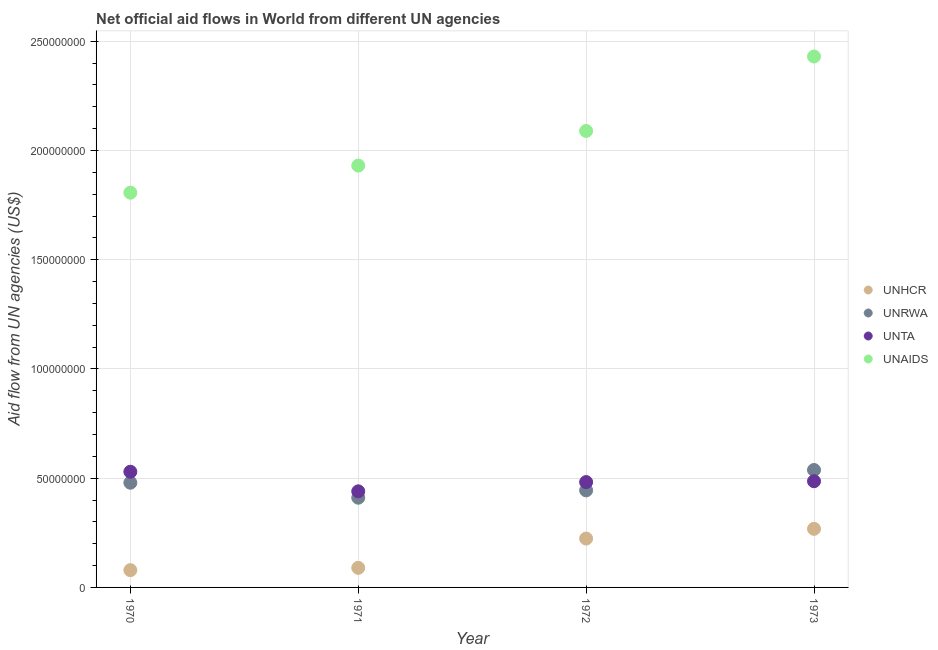How many different coloured dotlines are there?
Ensure brevity in your answer.  4. What is the amount of aid given by unta in 1970?
Ensure brevity in your answer.  5.30e+07. Across all years, what is the maximum amount of aid given by unhcr?
Keep it short and to the point. 2.68e+07. Across all years, what is the minimum amount of aid given by unta?
Your response must be concise. 4.40e+07. In which year was the amount of aid given by unaids minimum?
Give a very brief answer. 1970. What is the total amount of aid given by unrwa in the graph?
Your response must be concise. 1.87e+08. What is the difference between the amount of aid given by unaids in 1972 and that in 1973?
Your response must be concise. -3.41e+07. What is the difference between the amount of aid given by unaids in 1970 and the amount of aid given by unta in 1971?
Make the answer very short. 1.37e+08. What is the average amount of aid given by unaids per year?
Your response must be concise. 2.06e+08. In the year 1973, what is the difference between the amount of aid given by unhcr and amount of aid given by unta?
Provide a succinct answer. -2.18e+07. In how many years, is the amount of aid given by unrwa greater than 150000000 US$?
Offer a terse response. 0. What is the ratio of the amount of aid given by unrwa in 1971 to that in 1973?
Your answer should be compact. 0.76. What is the difference between the highest and the second highest amount of aid given by unaids?
Provide a short and direct response. 3.41e+07. What is the difference between the highest and the lowest amount of aid given by unaids?
Your response must be concise. 6.23e+07. In how many years, is the amount of aid given by unhcr greater than the average amount of aid given by unhcr taken over all years?
Your answer should be compact. 2. Is it the case that in every year, the sum of the amount of aid given by unrwa and amount of aid given by unaids is greater than the sum of amount of aid given by unta and amount of aid given by unhcr?
Make the answer very short. Yes. Is it the case that in every year, the sum of the amount of aid given by unhcr and amount of aid given by unrwa is greater than the amount of aid given by unta?
Provide a succinct answer. Yes. Does the amount of aid given by unta monotonically increase over the years?
Make the answer very short. No. Is the amount of aid given by unhcr strictly greater than the amount of aid given by unaids over the years?
Your answer should be compact. No. How many years are there in the graph?
Offer a terse response. 4. Are the values on the major ticks of Y-axis written in scientific E-notation?
Your answer should be very brief. No. Does the graph contain any zero values?
Your response must be concise. No. Does the graph contain grids?
Provide a short and direct response. Yes. How many legend labels are there?
Keep it short and to the point. 4. How are the legend labels stacked?
Make the answer very short. Vertical. What is the title of the graph?
Provide a succinct answer. Net official aid flows in World from different UN agencies. What is the label or title of the Y-axis?
Make the answer very short. Aid flow from UN agencies (US$). What is the Aid flow from UN agencies (US$) of UNHCR in 1970?
Your answer should be compact. 7.91e+06. What is the Aid flow from UN agencies (US$) of UNRWA in 1970?
Your answer should be very brief. 4.79e+07. What is the Aid flow from UN agencies (US$) of UNTA in 1970?
Your answer should be very brief. 5.30e+07. What is the Aid flow from UN agencies (US$) in UNAIDS in 1970?
Offer a terse response. 1.81e+08. What is the Aid flow from UN agencies (US$) of UNHCR in 1971?
Make the answer very short. 8.97e+06. What is the Aid flow from UN agencies (US$) of UNRWA in 1971?
Provide a short and direct response. 4.11e+07. What is the Aid flow from UN agencies (US$) of UNTA in 1971?
Give a very brief answer. 4.40e+07. What is the Aid flow from UN agencies (US$) in UNAIDS in 1971?
Keep it short and to the point. 1.93e+08. What is the Aid flow from UN agencies (US$) of UNHCR in 1972?
Keep it short and to the point. 2.24e+07. What is the Aid flow from UN agencies (US$) of UNRWA in 1972?
Ensure brevity in your answer.  4.44e+07. What is the Aid flow from UN agencies (US$) in UNTA in 1972?
Provide a short and direct response. 4.82e+07. What is the Aid flow from UN agencies (US$) of UNAIDS in 1972?
Your response must be concise. 2.09e+08. What is the Aid flow from UN agencies (US$) in UNHCR in 1973?
Offer a very short reply. 2.68e+07. What is the Aid flow from UN agencies (US$) in UNRWA in 1973?
Offer a terse response. 5.38e+07. What is the Aid flow from UN agencies (US$) of UNTA in 1973?
Make the answer very short. 4.86e+07. What is the Aid flow from UN agencies (US$) of UNAIDS in 1973?
Keep it short and to the point. 2.43e+08. Across all years, what is the maximum Aid flow from UN agencies (US$) in UNHCR?
Offer a terse response. 2.68e+07. Across all years, what is the maximum Aid flow from UN agencies (US$) of UNRWA?
Offer a very short reply. 5.38e+07. Across all years, what is the maximum Aid flow from UN agencies (US$) of UNTA?
Provide a short and direct response. 5.30e+07. Across all years, what is the maximum Aid flow from UN agencies (US$) in UNAIDS?
Offer a terse response. 2.43e+08. Across all years, what is the minimum Aid flow from UN agencies (US$) in UNHCR?
Give a very brief answer. 7.91e+06. Across all years, what is the minimum Aid flow from UN agencies (US$) in UNRWA?
Provide a succinct answer. 4.11e+07. Across all years, what is the minimum Aid flow from UN agencies (US$) in UNTA?
Offer a very short reply. 4.40e+07. Across all years, what is the minimum Aid flow from UN agencies (US$) of UNAIDS?
Your answer should be very brief. 1.81e+08. What is the total Aid flow from UN agencies (US$) in UNHCR in the graph?
Your response must be concise. 6.61e+07. What is the total Aid flow from UN agencies (US$) of UNRWA in the graph?
Provide a short and direct response. 1.87e+08. What is the total Aid flow from UN agencies (US$) in UNTA in the graph?
Ensure brevity in your answer.  1.94e+08. What is the total Aid flow from UN agencies (US$) in UNAIDS in the graph?
Your response must be concise. 8.26e+08. What is the difference between the Aid flow from UN agencies (US$) in UNHCR in 1970 and that in 1971?
Keep it short and to the point. -1.06e+06. What is the difference between the Aid flow from UN agencies (US$) of UNRWA in 1970 and that in 1971?
Your answer should be compact. 6.87e+06. What is the difference between the Aid flow from UN agencies (US$) of UNTA in 1970 and that in 1971?
Offer a terse response. 8.97e+06. What is the difference between the Aid flow from UN agencies (US$) in UNAIDS in 1970 and that in 1971?
Offer a very short reply. -1.24e+07. What is the difference between the Aid flow from UN agencies (US$) of UNHCR in 1970 and that in 1972?
Your answer should be compact. -1.45e+07. What is the difference between the Aid flow from UN agencies (US$) in UNRWA in 1970 and that in 1972?
Ensure brevity in your answer.  3.51e+06. What is the difference between the Aid flow from UN agencies (US$) of UNTA in 1970 and that in 1972?
Your response must be concise. 4.74e+06. What is the difference between the Aid flow from UN agencies (US$) of UNAIDS in 1970 and that in 1972?
Keep it short and to the point. -2.83e+07. What is the difference between the Aid flow from UN agencies (US$) in UNHCR in 1970 and that in 1973?
Offer a terse response. -1.89e+07. What is the difference between the Aid flow from UN agencies (US$) of UNRWA in 1970 and that in 1973?
Provide a succinct answer. -5.82e+06. What is the difference between the Aid flow from UN agencies (US$) of UNTA in 1970 and that in 1973?
Provide a succinct answer. 4.35e+06. What is the difference between the Aid flow from UN agencies (US$) in UNAIDS in 1970 and that in 1973?
Provide a short and direct response. -6.23e+07. What is the difference between the Aid flow from UN agencies (US$) of UNHCR in 1971 and that in 1972?
Your answer should be very brief. -1.34e+07. What is the difference between the Aid flow from UN agencies (US$) of UNRWA in 1971 and that in 1972?
Your response must be concise. -3.36e+06. What is the difference between the Aid flow from UN agencies (US$) of UNTA in 1971 and that in 1972?
Provide a succinct answer. -4.23e+06. What is the difference between the Aid flow from UN agencies (US$) of UNAIDS in 1971 and that in 1972?
Your answer should be compact. -1.58e+07. What is the difference between the Aid flow from UN agencies (US$) in UNHCR in 1971 and that in 1973?
Provide a succinct answer. -1.78e+07. What is the difference between the Aid flow from UN agencies (US$) of UNRWA in 1971 and that in 1973?
Provide a short and direct response. -1.27e+07. What is the difference between the Aid flow from UN agencies (US$) of UNTA in 1971 and that in 1973?
Keep it short and to the point. -4.62e+06. What is the difference between the Aid flow from UN agencies (US$) in UNAIDS in 1971 and that in 1973?
Keep it short and to the point. -4.99e+07. What is the difference between the Aid flow from UN agencies (US$) of UNHCR in 1972 and that in 1973?
Provide a short and direct response. -4.45e+06. What is the difference between the Aid flow from UN agencies (US$) of UNRWA in 1972 and that in 1973?
Your answer should be very brief. -9.33e+06. What is the difference between the Aid flow from UN agencies (US$) of UNTA in 1972 and that in 1973?
Your answer should be very brief. -3.90e+05. What is the difference between the Aid flow from UN agencies (US$) of UNAIDS in 1972 and that in 1973?
Make the answer very short. -3.41e+07. What is the difference between the Aid flow from UN agencies (US$) in UNHCR in 1970 and the Aid flow from UN agencies (US$) in UNRWA in 1971?
Make the answer very short. -3.32e+07. What is the difference between the Aid flow from UN agencies (US$) of UNHCR in 1970 and the Aid flow from UN agencies (US$) of UNTA in 1971?
Make the answer very short. -3.61e+07. What is the difference between the Aid flow from UN agencies (US$) of UNHCR in 1970 and the Aid flow from UN agencies (US$) of UNAIDS in 1971?
Give a very brief answer. -1.85e+08. What is the difference between the Aid flow from UN agencies (US$) of UNRWA in 1970 and the Aid flow from UN agencies (US$) of UNTA in 1971?
Provide a succinct answer. 3.94e+06. What is the difference between the Aid flow from UN agencies (US$) in UNRWA in 1970 and the Aid flow from UN agencies (US$) in UNAIDS in 1971?
Give a very brief answer. -1.45e+08. What is the difference between the Aid flow from UN agencies (US$) of UNTA in 1970 and the Aid flow from UN agencies (US$) of UNAIDS in 1971?
Ensure brevity in your answer.  -1.40e+08. What is the difference between the Aid flow from UN agencies (US$) in UNHCR in 1970 and the Aid flow from UN agencies (US$) in UNRWA in 1972?
Give a very brief answer. -3.65e+07. What is the difference between the Aid flow from UN agencies (US$) in UNHCR in 1970 and the Aid flow from UN agencies (US$) in UNTA in 1972?
Your answer should be very brief. -4.03e+07. What is the difference between the Aid flow from UN agencies (US$) in UNHCR in 1970 and the Aid flow from UN agencies (US$) in UNAIDS in 1972?
Provide a short and direct response. -2.01e+08. What is the difference between the Aid flow from UN agencies (US$) in UNRWA in 1970 and the Aid flow from UN agencies (US$) in UNAIDS in 1972?
Provide a short and direct response. -1.61e+08. What is the difference between the Aid flow from UN agencies (US$) of UNTA in 1970 and the Aid flow from UN agencies (US$) of UNAIDS in 1972?
Ensure brevity in your answer.  -1.56e+08. What is the difference between the Aid flow from UN agencies (US$) of UNHCR in 1970 and the Aid flow from UN agencies (US$) of UNRWA in 1973?
Keep it short and to the point. -4.58e+07. What is the difference between the Aid flow from UN agencies (US$) of UNHCR in 1970 and the Aid flow from UN agencies (US$) of UNTA in 1973?
Provide a succinct answer. -4.07e+07. What is the difference between the Aid flow from UN agencies (US$) in UNHCR in 1970 and the Aid flow from UN agencies (US$) in UNAIDS in 1973?
Your answer should be very brief. -2.35e+08. What is the difference between the Aid flow from UN agencies (US$) in UNRWA in 1970 and the Aid flow from UN agencies (US$) in UNTA in 1973?
Provide a succinct answer. -6.80e+05. What is the difference between the Aid flow from UN agencies (US$) in UNRWA in 1970 and the Aid flow from UN agencies (US$) in UNAIDS in 1973?
Keep it short and to the point. -1.95e+08. What is the difference between the Aid flow from UN agencies (US$) in UNTA in 1970 and the Aid flow from UN agencies (US$) in UNAIDS in 1973?
Offer a terse response. -1.90e+08. What is the difference between the Aid flow from UN agencies (US$) of UNHCR in 1971 and the Aid flow from UN agencies (US$) of UNRWA in 1972?
Ensure brevity in your answer.  -3.54e+07. What is the difference between the Aid flow from UN agencies (US$) in UNHCR in 1971 and the Aid flow from UN agencies (US$) in UNTA in 1972?
Your answer should be very brief. -3.92e+07. What is the difference between the Aid flow from UN agencies (US$) in UNHCR in 1971 and the Aid flow from UN agencies (US$) in UNAIDS in 1972?
Keep it short and to the point. -2.00e+08. What is the difference between the Aid flow from UN agencies (US$) in UNRWA in 1971 and the Aid flow from UN agencies (US$) in UNTA in 1972?
Provide a succinct answer. -7.16e+06. What is the difference between the Aid flow from UN agencies (US$) in UNRWA in 1971 and the Aid flow from UN agencies (US$) in UNAIDS in 1972?
Offer a terse response. -1.68e+08. What is the difference between the Aid flow from UN agencies (US$) of UNTA in 1971 and the Aid flow from UN agencies (US$) of UNAIDS in 1972?
Give a very brief answer. -1.65e+08. What is the difference between the Aid flow from UN agencies (US$) in UNHCR in 1971 and the Aid flow from UN agencies (US$) in UNRWA in 1973?
Provide a succinct answer. -4.48e+07. What is the difference between the Aid flow from UN agencies (US$) of UNHCR in 1971 and the Aid flow from UN agencies (US$) of UNTA in 1973?
Make the answer very short. -3.96e+07. What is the difference between the Aid flow from UN agencies (US$) of UNHCR in 1971 and the Aid flow from UN agencies (US$) of UNAIDS in 1973?
Provide a succinct answer. -2.34e+08. What is the difference between the Aid flow from UN agencies (US$) in UNRWA in 1971 and the Aid flow from UN agencies (US$) in UNTA in 1973?
Provide a succinct answer. -7.55e+06. What is the difference between the Aid flow from UN agencies (US$) of UNRWA in 1971 and the Aid flow from UN agencies (US$) of UNAIDS in 1973?
Your response must be concise. -2.02e+08. What is the difference between the Aid flow from UN agencies (US$) of UNTA in 1971 and the Aid flow from UN agencies (US$) of UNAIDS in 1973?
Provide a succinct answer. -1.99e+08. What is the difference between the Aid flow from UN agencies (US$) of UNHCR in 1972 and the Aid flow from UN agencies (US$) of UNRWA in 1973?
Make the answer very short. -3.14e+07. What is the difference between the Aid flow from UN agencies (US$) in UNHCR in 1972 and the Aid flow from UN agencies (US$) in UNTA in 1973?
Ensure brevity in your answer.  -2.62e+07. What is the difference between the Aid flow from UN agencies (US$) of UNHCR in 1972 and the Aid flow from UN agencies (US$) of UNAIDS in 1973?
Offer a terse response. -2.21e+08. What is the difference between the Aid flow from UN agencies (US$) in UNRWA in 1972 and the Aid flow from UN agencies (US$) in UNTA in 1973?
Your response must be concise. -4.19e+06. What is the difference between the Aid flow from UN agencies (US$) in UNRWA in 1972 and the Aid flow from UN agencies (US$) in UNAIDS in 1973?
Your answer should be very brief. -1.99e+08. What is the difference between the Aid flow from UN agencies (US$) of UNTA in 1972 and the Aid flow from UN agencies (US$) of UNAIDS in 1973?
Make the answer very short. -1.95e+08. What is the average Aid flow from UN agencies (US$) of UNHCR per year?
Offer a terse response. 1.65e+07. What is the average Aid flow from UN agencies (US$) in UNRWA per year?
Keep it short and to the point. 4.68e+07. What is the average Aid flow from UN agencies (US$) of UNTA per year?
Your answer should be compact. 4.84e+07. What is the average Aid flow from UN agencies (US$) in UNAIDS per year?
Offer a terse response. 2.06e+08. In the year 1970, what is the difference between the Aid flow from UN agencies (US$) in UNHCR and Aid flow from UN agencies (US$) in UNRWA?
Offer a terse response. -4.00e+07. In the year 1970, what is the difference between the Aid flow from UN agencies (US$) of UNHCR and Aid flow from UN agencies (US$) of UNTA?
Ensure brevity in your answer.  -4.50e+07. In the year 1970, what is the difference between the Aid flow from UN agencies (US$) of UNHCR and Aid flow from UN agencies (US$) of UNAIDS?
Your answer should be compact. -1.73e+08. In the year 1970, what is the difference between the Aid flow from UN agencies (US$) in UNRWA and Aid flow from UN agencies (US$) in UNTA?
Your answer should be very brief. -5.03e+06. In the year 1970, what is the difference between the Aid flow from UN agencies (US$) in UNRWA and Aid flow from UN agencies (US$) in UNAIDS?
Your response must be concise. -1.33e+08. In the year 1970, what is the difference between the Aid flow from UN agencies (US$) of UNTA and Aid flow from UN agencies (US$) of UNAIDS?
Give a very brief answer. -1.28e+08. In the year 1971, what is the difference between the Aid flow from UN agencies (US$) of UNHCR and Aid flow from UN agencies (US$) of UNRWA?
Provide a short and direct response. -3.21e+07. In the year 1971, what is the difference between the Aid flow from UN agencies (US$) of UNHCR and Aid flow from UN agencies (US$) of UNTA?
Keep it short and to the point. -3.50e+07. In the year 1971, what is the difference between the Aid flow from UN agencies (US$) in UNHCR and Aid flow from UN agencies (US$) in UNAIDS?
Give a very brief answer. -1.84e+08. In the year 1971, what is the difference between the Aid flow from UN agencies (US$) in UNRWA and Aid flow from UN agencies (US$) in UNTA?
Provide a short and direct response. -2.93e+06. In the year 1971, what is the difference between the Aid flow from UN agencies (US$) in UNRWA and Aid flow from UN agencies (US$) in UNAIDS?
Ensure brevity in your answer.  -1.52e+08. In the year 1971, what is the difference between the Aid flow from UN agencies (US$) in UNTA and Aid flow from UN agencies (US$) in UNAIDS?
Your answer should be very brief. -1.49e+08. In the year 1972, what is the difference between the Aid flow from UN agencies (US$) of UNHCR and Aid flow from UN agencies (US$) of UNRWA?
Offer a terse response. -2.20e+07. In the year 1972, what is the difference between the Aid flow from UN agencies (US$) of UNHCR and Aid flow from UN agencies (US$) of UNTA?
Provide a short and direct response. -2.58e+07. In the year 1972, what is the difference between the Aid flow from UN agencies (US$) of UNHCR and Aid flow from UN agencies (US$) of UNAIDS?
Make the answer very short. -1.87e+08. In the year 1972, what is the difference between the Aid flow from UN agencies (US$) in UNRWA and Aid flow from UN agencies (US$) in UNTA?
Offer a very short reply. -3.80e+06. In the year 1972, what is the difference between the Aid flow from UN agencies (US$) in UNRWA and Aid flow from UN agencies (US$) in UNAIDS?
Your response must be concise. -1.65e+08. In the year 1972, what is the difference between the Aid flow from UN agencies (US$) in UNTA and Aid flow from UN agencies (US$) in UNAIDS?
Offer a very short reply. -1.61e+08. In the year 1973, what is the difference between the Aid flow from UN agencies (US$) in UNHCR and Aid flow from UN agencies (US$) in UNRWA?
Your answer should be compact. -2.69e+07. In the year 1973, what is the difference between the Aid flow from UN agencies (US$) of UNHCR and Aid flow from UN agencies (US$) of UNTA?
Make the answer very short. -2.18e+07. In the year 1973, what is the difference between the Aid flow from UN agencies (US$) of UNHCR and Aid flow from UN agencies (US$) of UNAIDS?
Give a very brief answer. -2.16e+08. In the year 1973, what is the difference between the Aid flow from UN agencies (US$) in UNRWA and Aid flow from UN agencies (US$) in UNTA?
Your answer should be compact. 5.14e+06. In the year 1973, what is the difference between the Aid flow from UN agencies (US$) of UNRWA and Aid flow from UN agencies (US$) of UNAIDS?
Your answer should be compact. -1.89e+08. In the year 1973, what is the difference between the Aid flow from UN agencies (US$) in UNTA and Aid flow from UN agencies (US$) in UNAIDS?
Provide a short and direct response. -1.94e+08. What is the ratio of the Aid flow from UN agencies (US$) in UNHCR in 1970 to that in 1971?
Ensure brevity in your answer.  0.88. What is the ratio of the Aid flow from UN agencies (US$) in UNRWA in 1970 to that in 1971?
Make the answer very short. 1.17. What is the ratio of the Aid flow from UN agencies (US$) of UNTA in 1970 to that in 1971?
Your response must be concise. 1.2. What is the ratio of the Aid flow from UN agencies (US$) of UNAIDS in 1970 to that in 1971?
Your answer should be compact. 0.94. What is the ratio of the Aid flow from UN agencies (US$) of UNHCR in 1970 to that in 1972?
Your answer should be compact. 0.35. What is the ratio of the Aid flow from UN agencies (US$) in UNRWA in 1970 to that in 1972?
Give a very brief answer. 1.08. What is the ratio of the Aid flow from UN agencies (US$) of UNTA in 1970 to that in 1972?
Offer a very short reply. 1.1. What is the ratio of the Aid flow from UN agencies (US$) of UNAIDS in 1970 to that in 1972?
Your answer should be compact. 0.86. What is the ratio of the Aid flow from UN agencies (US$) in UNHCR in 1970 to that in 1973?
Keep it short and to the point. 0.29. What is the ratio of the Aid flow from UN agencies (US$) in UNRWA in 1970 to that in 1973?
Your response must be concise. 0.89. What is the ratio of the Aid flow from UN agencies (US$) in UNTA in 1970 to that in 1973?
Offer a very short reply. 1.09. What is the ratio of the Aid flow from UN agencies (US$) of UNAIDS in 1970 to that in 1973?
Make the answer very short. 0.74. What is the ratio of the Aid flow from UN agencies (US$) in UNHCR in 1971 to that in 1972?
Provide a short and direct response. 0.4. What is the ratio of the Aid flow from UN agencies (US$) in UNRWA in 1971 to that in 1972?
Make the answer very short. 0.92. What is the ratio of the Aid flow from UN agencies (US$) in UNTA in 1971 to that in 1972?
Ensure brevity in your answer.  0.91. What is the ratio of the Aid flow from UN agencies (US$) in UNAIDS in 1971 to that in 1972?
Your answer should be very brief. 0.92. What is the ratio of the Aid flow from UN agencies (US$) of UNHCR in 1971 to that in 1973?
Provide a short and direct response. 0.33. What is the ratio of the Aid flow from UN agencies (US$) of UNRWA in 1971 to that in 1973?
Your answer should be very brief. 0.76. What is the ratio of the Aid flow from UN agencies (US$) in UNTA in 1971 to that in 1973?
Your answer should be compact. 0.91. What is the ratio of the Aid flow from UN agencies (US$) in UNAIDS in 1971 to that in 1973?
Offer a terse response. 0.79. What is the ratio of the Aid flow from UN agencies (US$) in UNHCR in 1972 to that in 1973?
Make the answer very short. 0.83. What is the ratio of the Aid flow from UN agencies (US$) in UNRWA in 1972 to that in 1973?
Give a very brief answer. 0.83. What is the ratio of the Aid flow from UN agencies (US$) of UNTA in 1972 to that in 1973?
Provide a short and direct response. 0.99. What is the ratio of the Aid flow from UN agencies (US$) in UNAIDS in 1972 to that in 1973?
Ensure brevity in your answer.  0.86. What is the difference between the highest and the second highest Aid flow from UN agencies (US$) of UNHCR?
Keep it short and to the point. 4.45e+06. What is the difference between the highest and the second highest Aid flow from UN agencies (US$) in UNRWA?
Give a very brief answer. 5.82e+06. What is the difference between the highest and the second highest Aid flow from UN agencies (US$) in UNTA?
Your answer should be very brief. 4.35e+06. What is the difference between the highest and the second highest Aid flow from UN agencies (US$) of UNAIDS?
Make the answer very short. 3.41e+07. What is the difference between the highest and the lowest Aid flow from UN agencies (US$) in UNHCR?
Offer a very short reply. 1.89e+07. What is the difference between the highest and the lowest Aid flow from UN agencies (US$) of UNRWA?
Offer a very short reply. 1.27e+07. What is the difference between the highest and the lowest Aid flow from UN agencies (US$) of UNTA?
Provide a short and direct response. 8.97e+06. What is the difference between the highest and the lowest Aid flow from UN agencies (US$) in UNAIDS?
Give a very brief answer. 6.23e+07. 